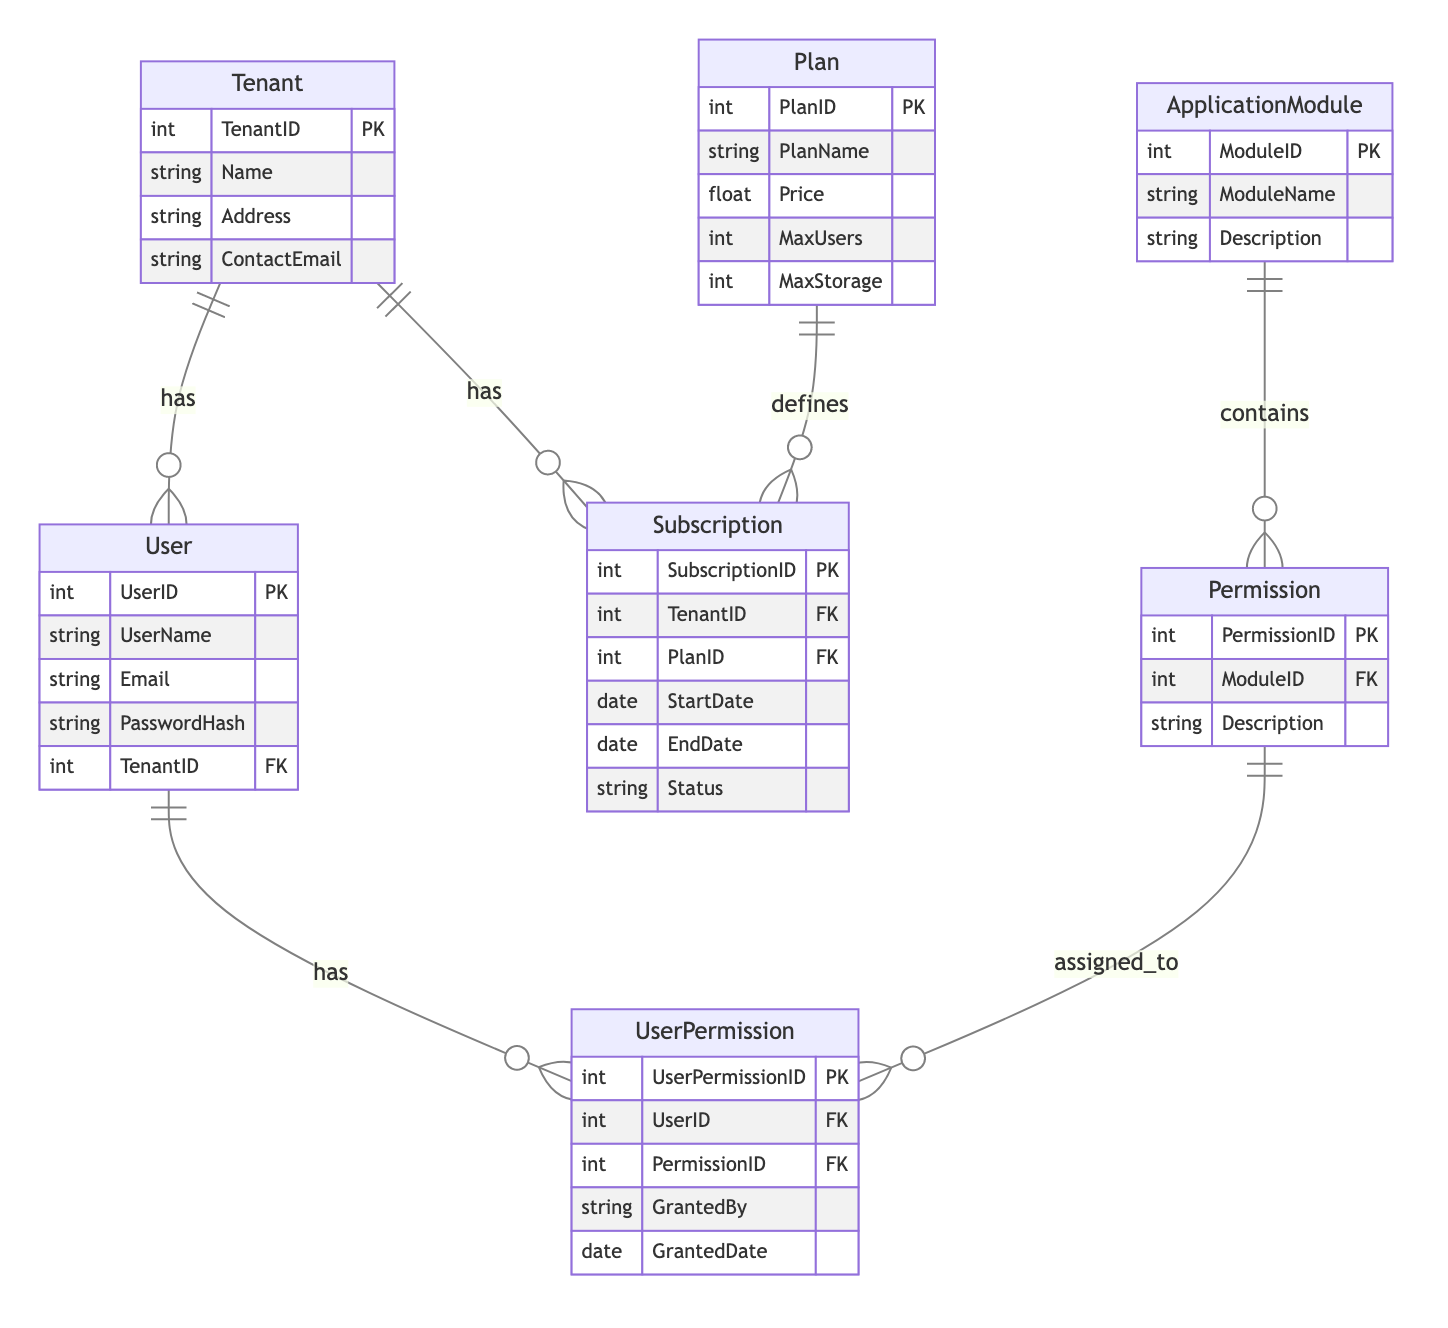What is the primary key of the Tenant entity? The primary key of the Tenant entity is TenantID, which uniquely identifies each tenant in the database.
Answer: TenantID How many relationships are defined between the Subscription and the Plan entities? There is one relationship named Plan_Subscription defined between the Plan and Subscription entities, indicating that each subscription is connected to one plan.
Answer: One What is the relationship type between the User and UserPermission entities? The relationship type between User and UserPermission is one-to-many, meaning one user can have multiple permissions assigned.
Answer: OneToMany Which entity includes the attribute MaxStorage? The attribute MaxStorage is included in the Plan entity, which describes the user's subscription limits.
Answer: Plan How many permissions can a User have at most? A user can have multiple permissions; the maximum would be determined by the subscription plan they are associated with, as the plan typically limits the number of users and storage, not permissions explicitly. However, the relationships show unlimited permissions exist for modules if allowed. Therefore, the exact number is not defined in the diagram.
Answer: Not defined Which entity contains a description of application modules? The ApplicationModule entity contains attributes that describe the various modules available in the application, including their names and functions.
Answer: ApplicationModule How are subscriptions related to tenants? Subscriptions are related to tenants with a one-to-many relationship, meaning a single tenant can have multiple subscriptions over time.
Answer: OneToMany What entity is associated with the concept of granting permissions? The UserPermission entity is associated with granting permissions, as it records the specific permissions assigned to users, including who granted them and when.
Answer: UserPermission What attribute links the User and Tenant entities? The TenantID attribute links the User and Tenant entities, allowing users to be associated with a specific tenant in the system.
Answer: TenantID 